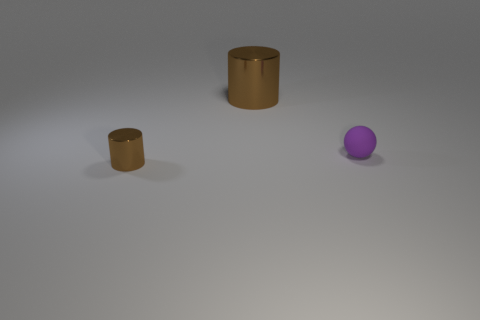Are there any other things that are the same material as the purple object?
Give a very brief answer. No. Does the large cylinder have the same material as the cylinder that is in front of the small rubber sphere?
Your answer should be compact. Yes. Is there another metal cylinder of the same color as the large cylinder?
Keep it short and to the point. Yes. How many other things are there of the same material as the small ball?
Your response must be concise. 0. There is a tiny metal thing; does it have the same color as the shiny thing that is behind the small cylinder?
Offer a very short reply. Yes. Is the number of large shiny things that are left of the purple matte object greater than the number of tiny yellow metal things?
Your answer should be compact. Yes. There is a small object that is behind the brown shiny cylinder left of the large brown thing; what number of metallic things are in front of it?
Your response must be concise. 1. There is a brown metal thing on the right side of the small brown cylinder; is its shape the same as the tiny brown metal thing?
Ensure brevity in your answer.  Yes. There is a tiny thing that is to the right of the big brown thing; what is its material?
Your response must be concise. Rubber. There is a thing that is on the right side of the small metal object and on the left side of the small rubber thing; what shape is it?
Your response must be concise. Cylinder. 